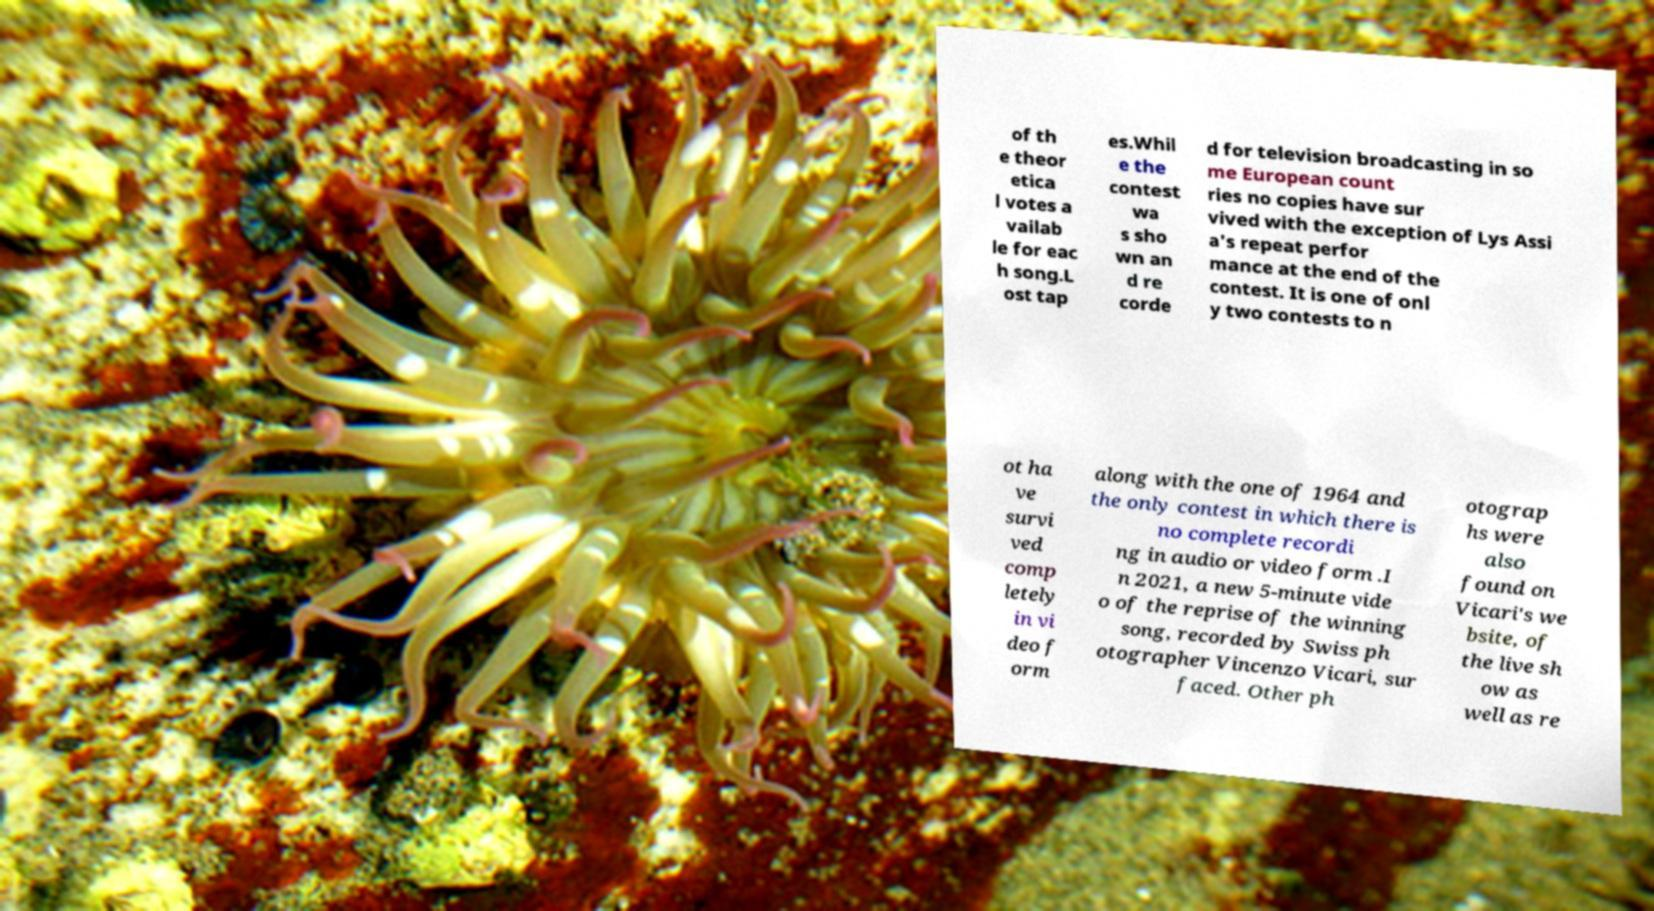There's text embedded in this image that I need extracted. Can you transcribe it verbatim? of th e theor etica l votes a vailab le for eac h song.L ost tap es.Whil e the contest wa s sho wn an d re corde d for television broadcasting in so me European count ries no copies have sur vived with the exception of Lys Assi a's repeat perfor mance at the end of the contest. It is one of onl y two contests to n ot ha ve survi ved comp letely in vi deo f orm along with the one of 1964 and the only contest in which there is no complete recordi ng in audio or video form .I n 2021, a new 5-minute vide o of the reprise of the winning song, recorded by Swiss ph otographer Vincenzo Vicari, sur faced. Other ph otograp hs were also found on Vicari's we bsite, of the live sh ow as well as re 